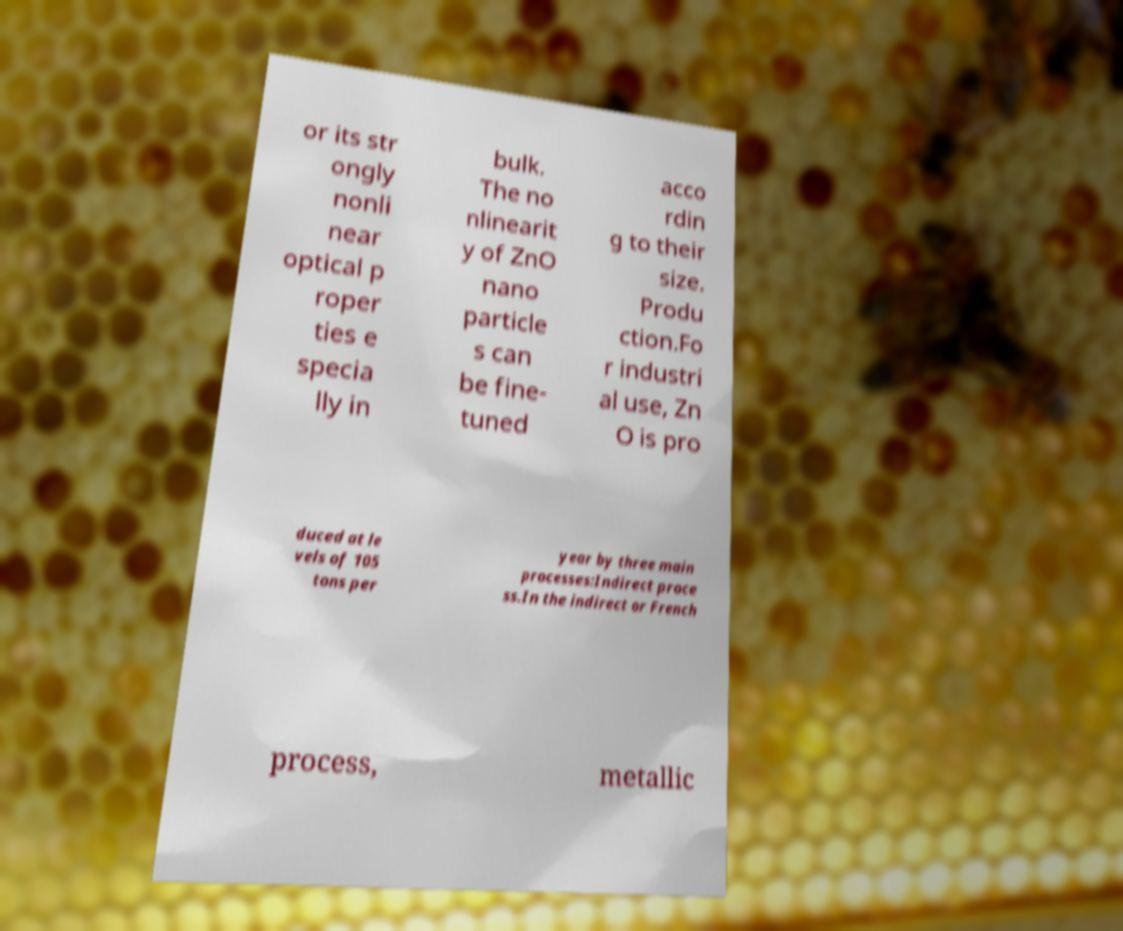There's text embedded in this image that I need extracted. Can you transcribe it verbatim? or its str ongly nonli near optical p roper ties e specia lly in bulk. The no nlinearit y of ZnO nano particle s can be fine- tuned acco rdin g to their size. Produ ction.Fo r industri al use, Zn O is pro duced at le vels of 105 tons per year by three main processes:Indirect proce ss.In the indirect or French process, metallic 